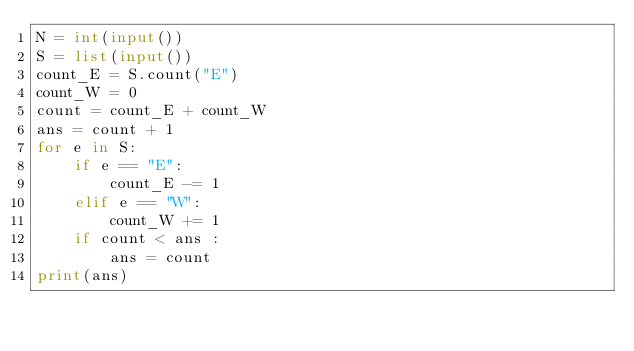Convert code to text. <code><loc_0><loc_0><loc_500><loc_500><_Python_>N = int(input())
S = list(input())
count_E = S.count("E")
count_W = 0
count = count_E + count_W
ans = count + 1
for e in S:
    if e == "E":
        count_E -= 1
    elif e == "W":
        count_W += 1
    if count < ans :
        ans = count
print(ans)</code> 